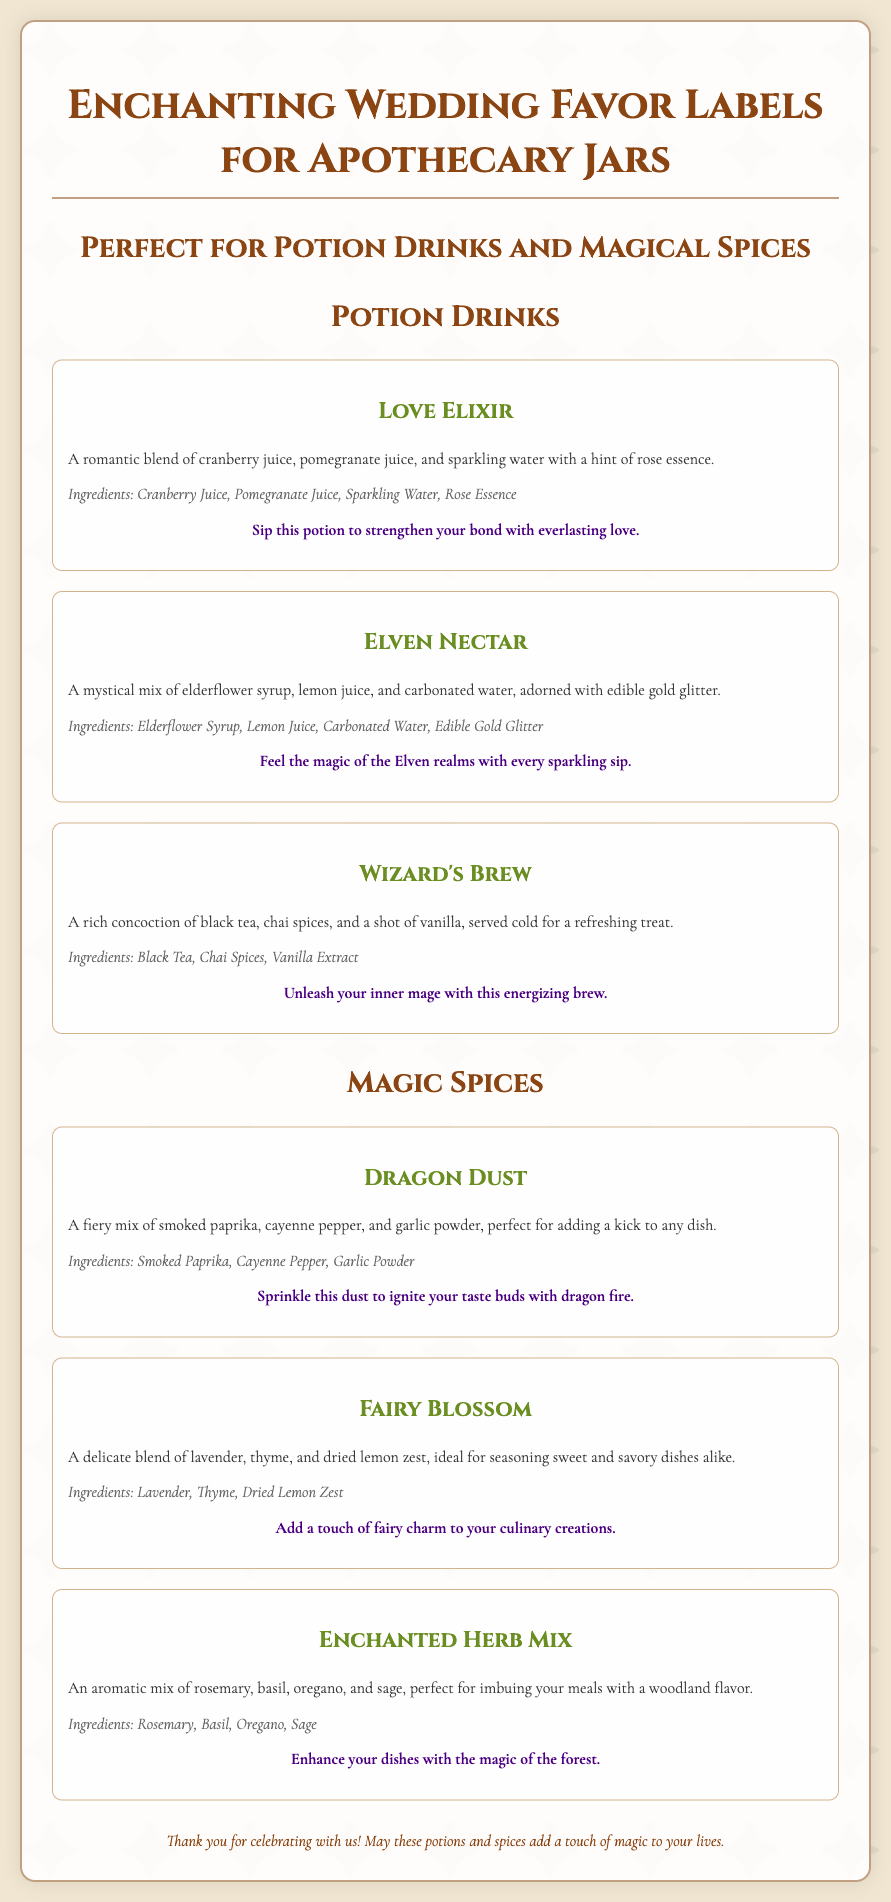What is the title of the document? The title of the document is prominently displayed at the top of the wrapper.
Answer: Enchanting Wedding Favor Labels What is the theme of the wedding favors? The theme of the wedding favors is reflected in the ingredients and label messages associated with the potion drinks and spices.
Answer: Fantasy How many potion drinks are listed? The number of potion drinks is calculated by counting the relevant sections in the document.
Answer: Three What ingredients are in the Love Elixir? The ingredients for Love Elixir are specified in the potion drink description section.
Answer: Cranberry Juice, Pomegranate Juice, Sparkling Water, Rose Essence What does "Dragon Dust" offer to dishes? The document provides a description of the effect Dragon Dust has on culinary creations.
Answer: Adds a kick What is one of the ingredients in the Fairy Blossom? The document lists out the ingredients for Fairy Blossom.
Answer: Lavender Which potion drink is associated with energizing? The label message for the potion drink mentions energizing qualities.
Answer: Wizard's Brew What is the color of the section titles? The color specifications for the section titles can be found in the styling section of the document.
Answer: Dark brown How does the document thank the guests? The conclusion of the document contains a thank you message directed toward the guests.
Answer: Thank you for celebrating with us! 